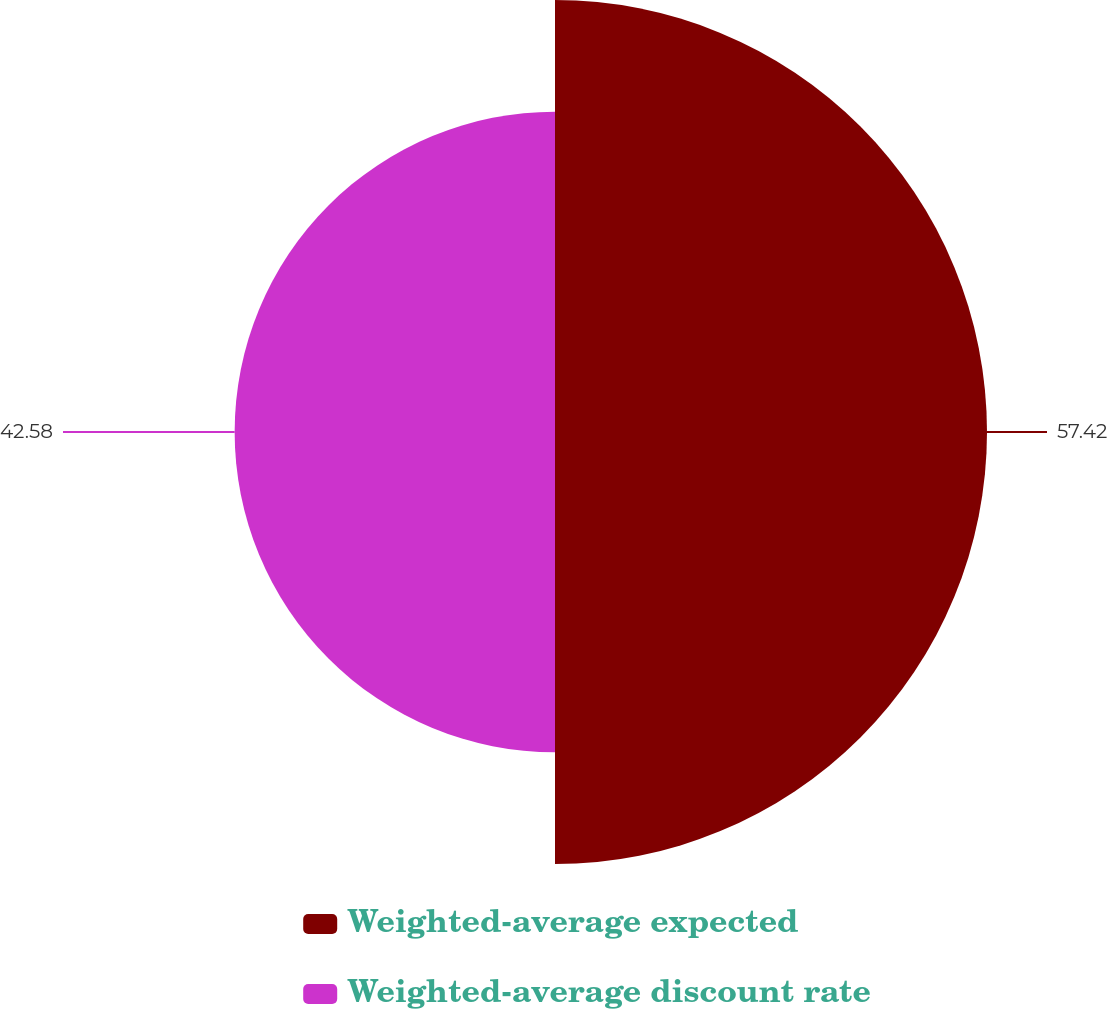Convert chart to OTSL. <chart><loc_0><loc_0><loc_500><loc_500><pie_chart><fcel>Weighted-average expected<fcel>Weighted-average discount rate<nl><fcel>57.42%<fcel>42.58%<nl></chart> 